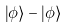Convert formula to latex. <formula><loc_0><loc_0><loc_500><loc_500>\left | \phi \right > - \left | \phi \right ></formula> 